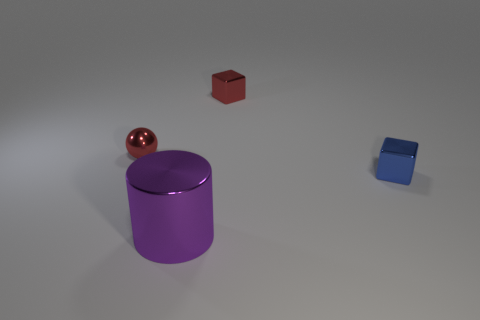What number of blue blocks are the same material as the small ball?
Offer a very short reply. 1. Is the shape of the large purple thing the same as the tiny object behind the tiny ball?
Give a very brief answer. No. Is there a red object that is left of the metal block that is right of the tiny metallic cube that is behind the metal ball?
Ensure brevity in your answer.  Yes. How big is the red thing to the left of the red cube?
Provide a succinct answer. Small. There is a red ball that is the same size as the red shiny cube; what material is it?
Your response must be concise. Metal. Does the small blue metallic object have the same shape as the large purple thing?
Provide a short and direct response. No. What number of things are large purple metal cylinders or small blue metal things that are to the right of the large shiny thing?
Give a very brief answer. 2. There is a small cube that is the same color as the metallic sphere; what is it made of?
Give a very brief answer. Metal. There is a red thing to the right of the purple cylinder; does it have the same size as the metal cylinder?
Ensure brevity in your answer.  No. What number of balls are behind the small red object left of the cube that is behind the tiny ball?
Ensure brevity in your answer.  0. 